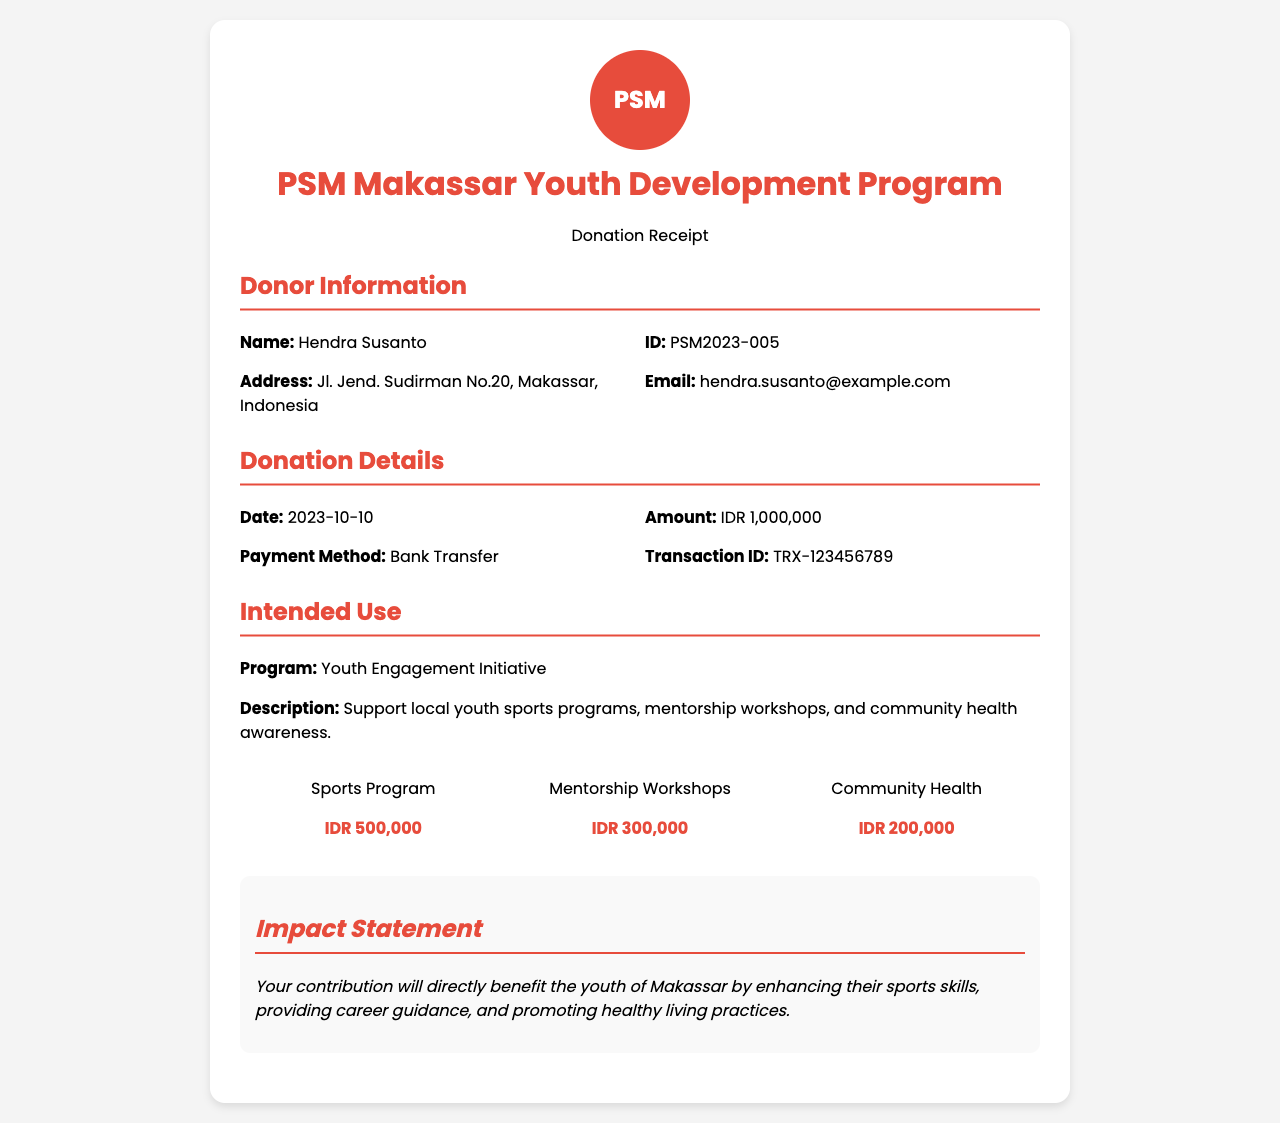What is the donor's name? The donor's name is found in the donor information section of the document.
Answer: Hendra Susanto What is the donation amount? The donation amount is specified in the donation details section of the receipt.
Answer: IDR 1,000,000 What is the date of the donation? The date can be found in the donation details section.
Answer: 2023-10-10 What is the payment method? The payment method used for the donation is listed in the donation details section.
Answer: Bank Transfer What program is being supported? The intended use section indicates which program is being supported.
Answer: Youth Engagement Initiative How much is allocated for the Sports Program? The fund distribution section shows how much is assigned to each initiative.
Answer: IDR 500,000 What part of the donation is for Community Health? The intended use section provides a breakdown of where the funds will be directed.
Answer: IDR 200,000 What is the purpose of the mentorship workshops? This can be inferred from the intended use section's description of the donation's impact.
Answer: Career guidance How will the donation impact the youth of Makassar? The impact statement details how the funds will benefit the youth in the community.
Answer: Enhancing sports skills, providing career guidance, and promoting healthy living practices 